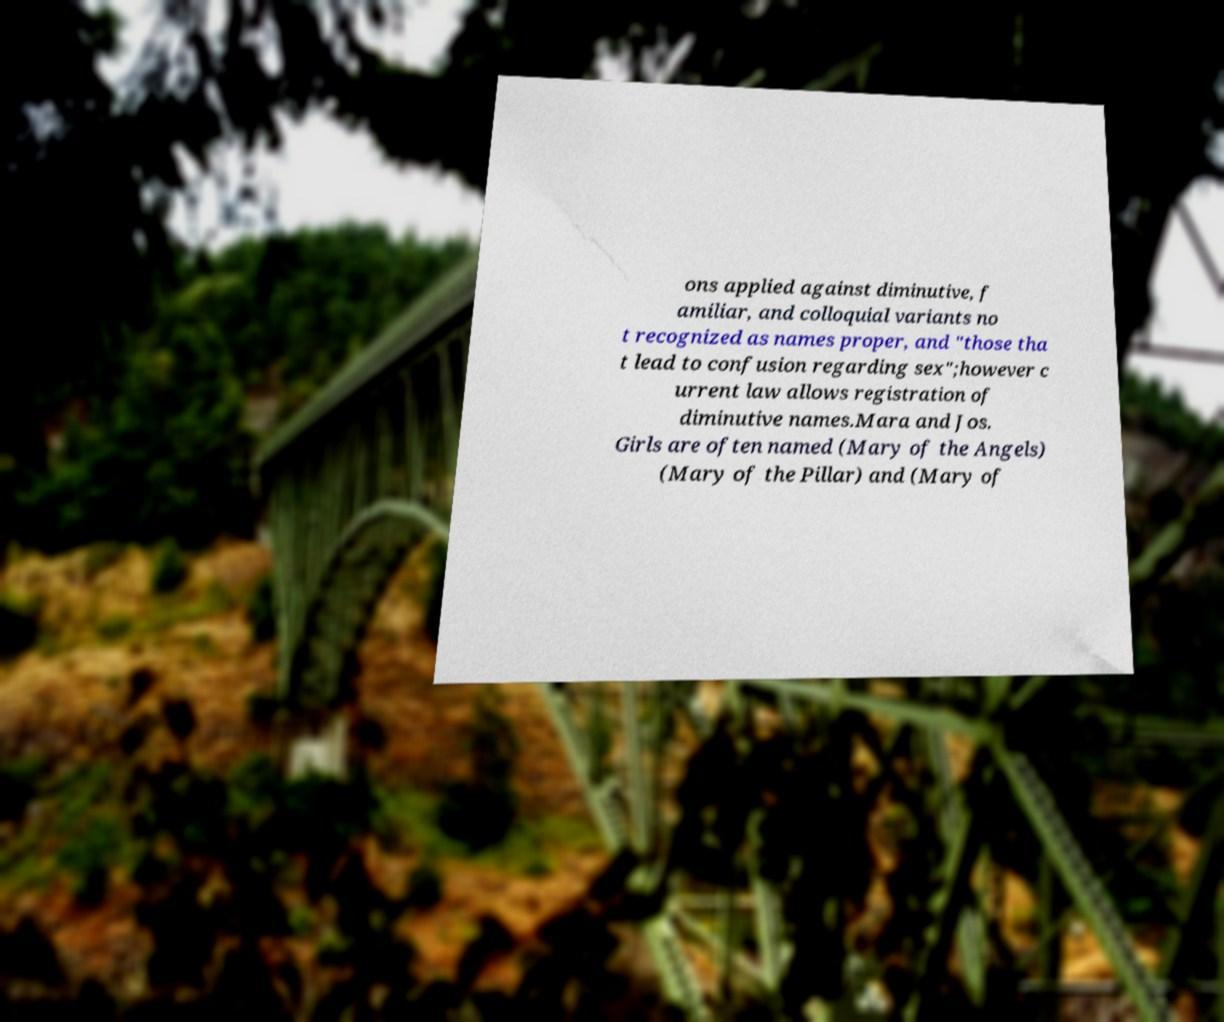There's text embedded in this image that I need extracted. Can you transcribe it verbatim? ons applied against diminutive, f amiliar, and colloquial variants no t recognized as names proper, and "those tha t lead to confusion regarding sex";however c urrent law allows registration of diminutive names.Mara and Jos. Girls are often named (Mary of the Angels) (Mary of the Pillar) and (Mary of 